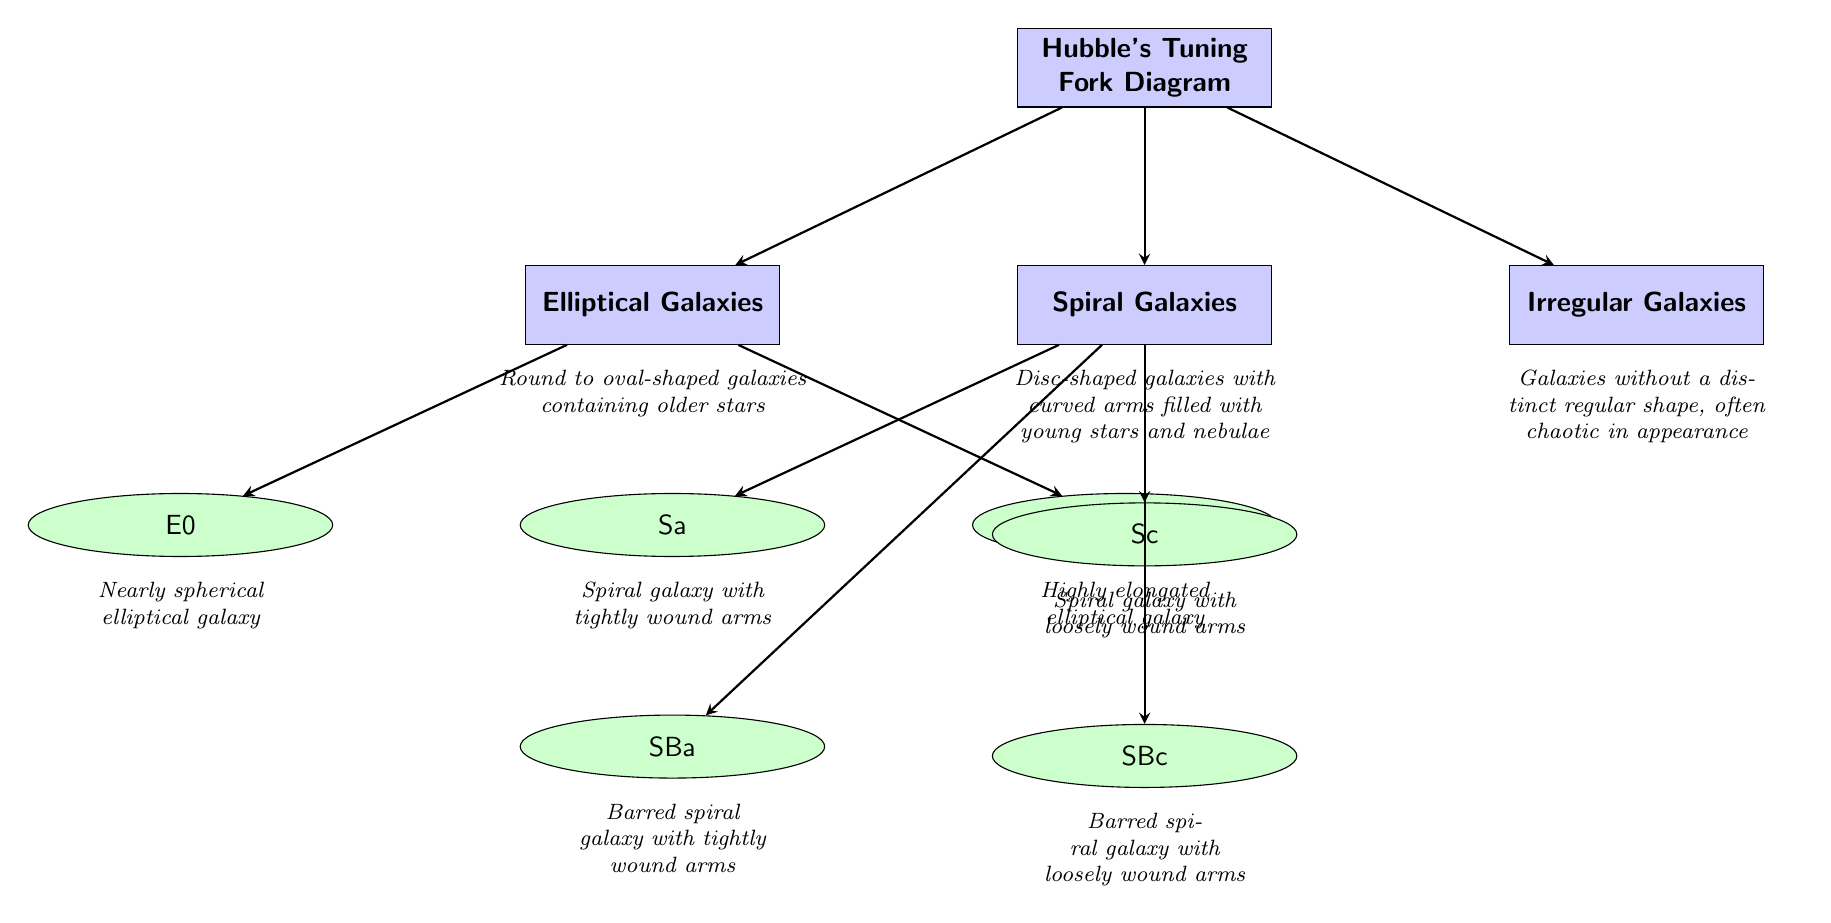What is the main topic of the diagram? The main topic of the diagram is presented at the top node labeled "Hubble's Tuning Fork Diagram," which serves as the central theme for the classification of galaxies.
Answer: Hubble's Tuning Fork Diagram How many types of galaxies are classified in the diagram? The diagram classifies three main types of galaxies: Elliptical, Spiral, and Irregular. This is evident from the three main nodes branching from the central node.
Answer: 3 What is the designation of the most spherical elliptical galaxy? The most spherical elliptical galaxy is designated as "E0," which is indicated in the sub-node branching from "Elliptical Galaxies."
Answer: E0 Which type of galaxy features "loosely wound arms"? The "Spiral Galaxies" type features "loosely wound arms," specifically under the designation "Sc." This is specified in the descriptions listed below the relevant node.
Answer: Sc Which type of galaxy has older stars? "Elliptical Galaxies" are described as having older stars, indicated in the description below the node representing "Elliptical Galaxies."
Answer: Elliptical Galaxies What distinguishes a barred spiral galaxy from a regular spiral galaxy? A barred spiral galaxy is distinguished by the presence of a bar-shaped structure, as noted specifically in the nodes "SBa" and "SBc," indicating that they are barred variants of spiral galaxies.
Answer: Bar-shaped structure Which type of galaxy is described as chaotic in appearance? The Irregular Galaxies are described as "galaxies without a distinct regular shape, often chaotic in appearance," according to the description provided below the "Irregular Galaxies" node.
Answer: Irregular Galaxies What node connects Elliptical and Spiral Galaxies in the diagram? The arrow connecting the nodes indicates that the central node "Hubble's Tuning Fork Diagram" is the common source that connects both the Elliptical and Spiral Galaxies nodes.
Answer: Hubble's Tuning Fork Diagram How many sub-types are identified under Spiral Galaxies? There are four sub-types identified under Spiral Galaxies: "Sa," "Sc," "SBa," and "SBc," which can be counted from the respective sub-nodes that branch off from the "Spiral Galaxies" node.
Answer: 4 